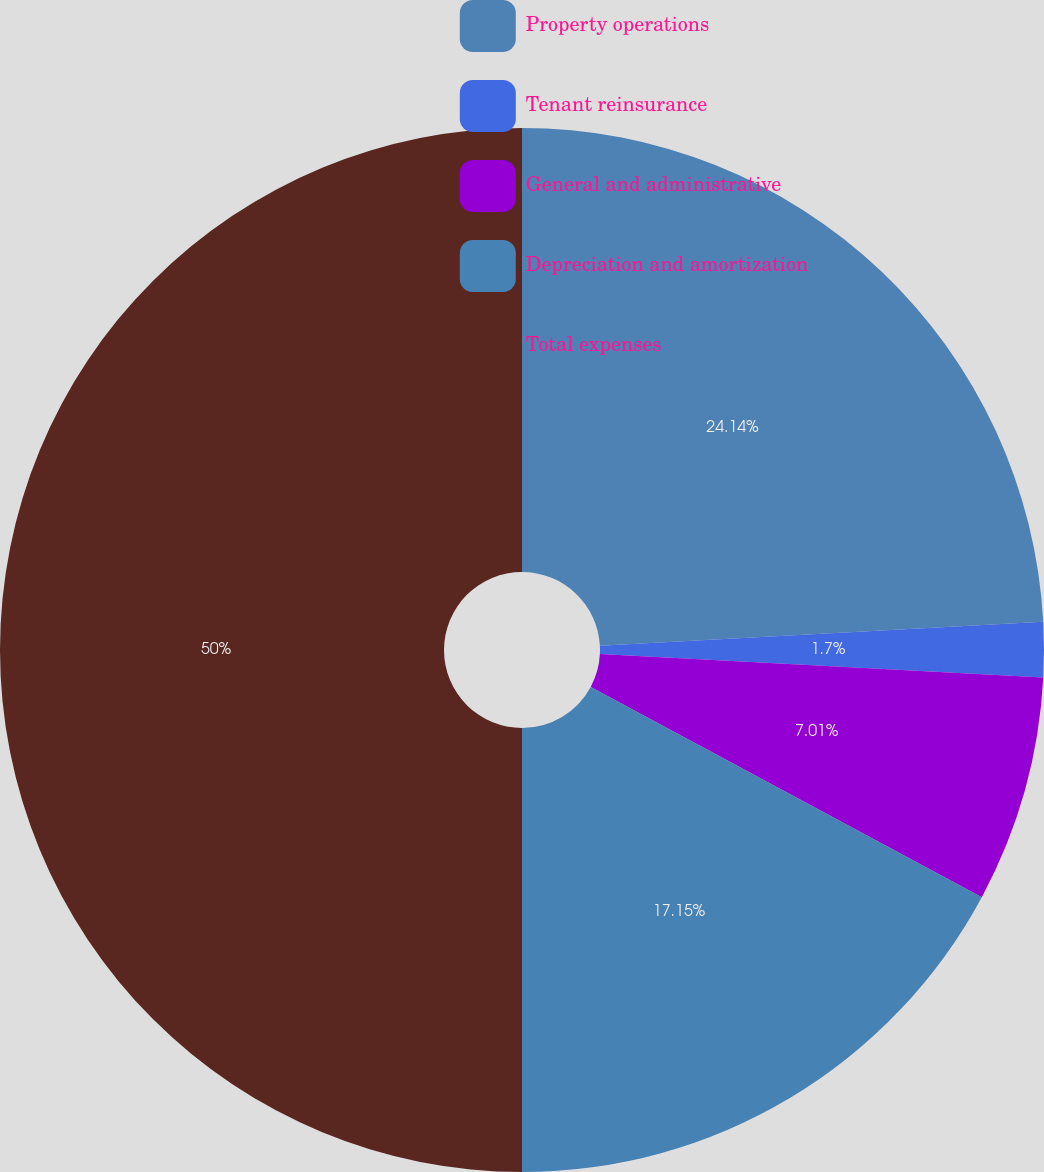Convert chart to OTSL. <chart><loc_0><loc_0><loc_500><loc_500><pie_chart><fcel>Property operations<fcel>Tenant reinsurance<fcel>General and administrative<fcel>Depreciation and amortization<fcel>Total expenses<nl><fcel>24.14%<fcel>1.7%<fcel>7.01%<fcel>17.15%<fcel>50.0%<nl></chart> 